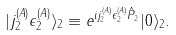<formula> <loc_0><loc_0><loc_500><loc_500>| j ^ { ( A ) } _ { 2 } \epsilon ^ { ( A ) } _ { 2 } \rangle _ { 2 } \equiv e ^ { i j ^ { ( A ) } _ { 2 } \epsilon ^ { ( A ) } _ { 2 } { \hat { P } } _ { 2 } } | 0 \rangle _ { 2 } .</formula> 